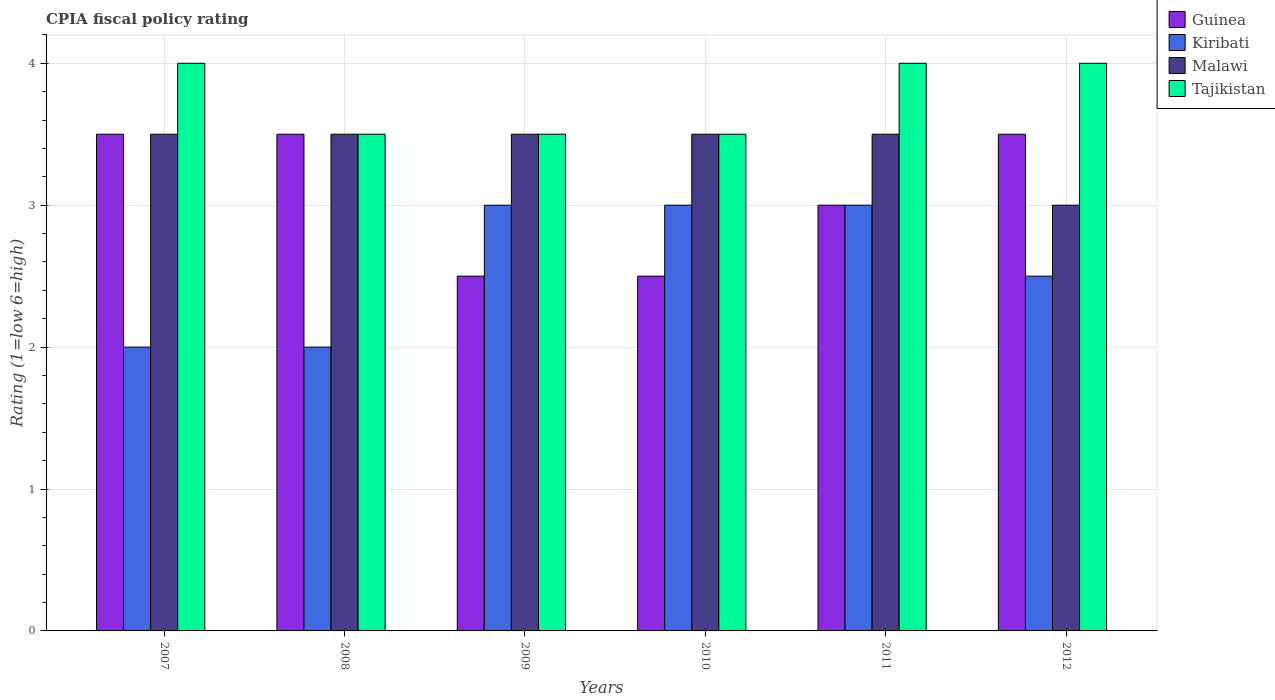How many groups of bars are there?
Ensure brevity in your answer.  6. Are the number of bars on each tick of the X-axis equal?
Provide a succinct answer. Yes. How many bars are there on the 3rd tick from the right?
Make the answer very short. 4. Across all years, what is the maximum CPIA rating in Tajikistan?
Your response must be concise. 4. In which year was the CPIA rating in Tajikistan minimum?
Your answer should be compact. 2008. What is the total CPIA rating in Kiribati in the graph?
Provide a succinct answer. 15.5. What is the difference between the CPIA rating in Kiribati in 2007 and the CPIA rating in Tajikistan in 2009?
Provide a succinct answer. -1.5. What is the average CPIA rating in Guinea per year?
Your answer should be very brief. 3.08. In the year 2012, what is the difference between the CPIA rating in Malawi and CPIA rating in Tajikistan?
Make the answer very short. -1. In how many years, is the CPIA rating in Guinea greater than 2.8?
Keep it short and to the point. 4. What is the ratio of the CPIA rating in Tajikistan in 2010 to that in 2012?
Provide a short and direct response. 0.88. Is the difference between the CPIA rating in Malawi in 2007 and 2012 greater than the difference between the CPIA rating in Tajikistan in 2007 and 2012?
Your answer should be very brief. Yes. What is the difference between the highest and the lowest CPIA rating in Guinea?
Make the answer very short. 1. In how many years, is the CPIA rating in Malawi greater than the average CPIA rating in Malawi taken over all years?
Ensure brevity in your answer.  5. What does the 1st bar from the left in 2010 represents?
Give a very brief answer. Guinea. What does the 4th bar from the right in 2012 represents?
Your answer should be very brief. Guinea. Is it the case that in every year, the sum of the CPIA rating in Guinea and CPIA rating in Malawi is greater than the CPIA rating in Kiribati?
Provide a succinct answer. Yes. Are all the bars in the graph horizontal?
Keep it short and to the point. No. Does the graph contain any zero values?
Keep it short and to the point. No. Does the graph contain grids?
Keep it short and to the point. Yes. Where does the legend appear in the graph?
Provide a succinct answer. Top right. How many legend labels are there?
Provide a succinct answer. 4. How are the legend labels stacked?
Offer a terse response. Vertical. What is the title of the graph?
Offer a very short reply. CPIA fiscal policy rating. What is the Rating (1=low 6=high) in Guinea in 2007?
Your response must be concise. 3.5. What is the Rating (1=low 6=high) in Malawi in 2007?
Make the answer very short. 3.5. What is the Rating (1=low 6=high) in Tajikistan in 2008?
Keep it short and to the point. 3.5. What is the Rating (1=low 6=high) of Kiribati in 2009?
Make the answer very short. 3. What is the Rating (1=low 6=high) of Malawi in 2009?
Offer a very short reply. 3.5. What is the Rating (1=low 6=high) in Malawi in 2010?
Provide a succinct answer. 3.5. What is the Rating (1=low 6=high) of Tajikistan in 2010?
Make the answer very short. 3.5. What is the Rating (1=low 6=high) of Kiribati in 2011?
Offer a terse response. 3. What is the Rating (1=low 6=high) of Guinea in 2012?
Provide a succinct answer. 3.5. What is the Rating (1=low 6=high) of Malawi in 2012?
Keep it short and to the point. 3. What is the Rating (1=low 6=high) of Tajikistan in 2012?
Provide a succinct answer. 4. Across all years, what is the maximum Rating (1=low 6=high) of Guinea?
Your answer should be very brief. 3.5. Across all years, what is the maximum Rating (1=low 6=high) of Tajikistan?
Make the answer very short. 4. Across all years, what is the minimum Rating (1=low 6=high) in Guinea?
Offer a very short reply. 2.5. Across all years, what is the minimum Rating (1=low 6=high) of Kiribati?
Provide a short and direct response. 2. Across all years, what is the minimum Rating (1=low 6=high) of Malawi?
Ensure brevity in your answer.  3. What is the total Rating (1=low 6=high) in Kiribati in the graph?
Ensure brevity in your answer.  15.5. What is the total Rating (1=low 6=high) in Tajikistan in the graph?
Your answer should be very brief. 22.5. What is the difference between the Rating (1=low 6=high) of Tajikistan in 2007 and that in 2008?
Provide a short and direct response. 0.5. What is the difference between the Rating (1=low 6=high) in Guinea in 2007 and that in 2009?
Ensure brevity in your answer.  1. What is the difference between the Rating (1=low 6=high) in Malawi in 2007 and that in 2009?
Ensure brevity in your answer.  0. What is the difference between the Rating (1=low 6=high) of Guinea in 2007 and that in 2010?
Your answer should be compact. 1. What is the difference between the Rating (1=low 6=high) in Malawi in 2007 and that in 2010?
Keep it short and to the point. 0. What is the difference between the Rating (1=low 6=high) in Malawi in 2007 and that in 2011?
Keep it short and to the point. 0. What is the difference between the Rating (1=low 6=high) in Tajikistan in 2007 and that in 2011?
Offer a terse response. 0. What is the difference between the Rating (1=low 6=high) of Malawi in 2007 and that in 2012?
Provide a short and direct response. 0.5. What is the difference between the Rating (1=low 6=high) of Tajikistan in 2008 and that in 2009?
Your response must be concise. 0. What is the difference between the Rating (1=low 6=high) in Malawi in 2008 and that in 2010?
Keep it short and to the point. 0. What is the difference between the Rating (1=low 6=high) of Tajikistan in 2008 and that in 2010?
Keep it short and to the point. 0. What is the difference between the Rating (1=low 6=high) in Kiribati in 2008 and that in 2011?
Give a very brief answer. -1. What is the difference between the Rating (1=low 6=high) of Malawi in 2008 and that in 2012?
Give a very brief answer. 0.5. What is the difference between the Rating (1=low 6=high) of Malawi in 2009 and that in 2010?
Give a very brief answer. 0. What is the difference between the Rating (1=low 6=high) of Guinea in 2009 and that in 2011?
Keep it short and to the point. -0.5. What is the difference between the Rating (1=low 6=high) of Malawi in 2009 and that in 2011?
Provide a short and direct response. 0. What is the difference between the Rating (1=low 6=high) of Kiribati in 2009 and that in 2012?
Your answer should be very brief. 0.5. What is the difference between the Rating (1=low 6=high) in Tajikistan in 2009 and that in 2012?
Give a very brief answer. -0.5. What is the difference between the Rating (1=low 6=high) of Guinea in 2010 and that in 2011?
Your answer should be very brief. -0.5. What is the difference between the Rating (1=low 6=high) in Kiribati in 2010 and that in 2012?
Provide a succinct answer. 0.5. What is the difference between the Rating (1=low 6=high) in Malawi in 2010 and that in 2012?
Your answer should be very brief. 0.5. What is the difference between the Rating (1=low 6=high) of Tajikistan in 2010 and that in 2012?
Offer a terse response. -0.5. What is the difference between the Rating (1=low 6=high) of Kiribati in 2011 and that in 2012?
Provide a succinct answer. 0.5. What is the difference between the Rating (1=low 6=high) of Guinea in 2007 and the Rating (1=low 6=high) of Malawi in 2008?
Your answer should be very brief. 0. What is the difference between the Rating (1=low 6=high) of Guinea in 2007 and the Rating (1=low 6=high) of Tajikistan in 2008?
Provide a succinct answer. 0. What is the difference between the Rating (1=low 6=high) of Kiribati in 2007 and the Rating (1=low 6=high) of Malawi in 2008?
Your answer should be compact. -1.5. What is the difference between the Rating (1=low 6=high) in Guinea in 2007 and the Rating (1=low 6=high) in Kiribati in 2009?
Ensure brevity in your answer.  0.5. What is the difference between the Rating (1=low 6=high) of Kiribati in 2007 and the Rating (1=low 6=high) of Tajikistan in 2009?
Your answer should be compact. -1.5. What is the difference between the Rating (1=low 6=high) of Guinea in 2007 and the Rating (1=low 6=high) of Kiribati in 2010?
Your response must be concise. 0.5. What is the difference between the Rating (1=low 6=high) of Guinea in 2007 and the Rating (1=low 6=high) of Malawi in 2010?
Offer a very short reply. 0. What is the difference between the Rating (1=low 6=high) in Guinea in 2007 and the Rating (1=low 6=high) in Tajikistan in 2010?
Ensure brevity in your answer.  0. What is the difference between the Rating (1=low 6=high) in Kiribati in 2007 and the Rating (1=low 6=high) in Tajikistan in 2010?
Offer a terse response. -1.5. What is the difference between the Rating (1=low 6=high) in Guinea in 2007 and the Rating (1=low 6=high) in Malawi in 2011?
Your answer should be compact. 0. What is the difference between the Rating (1=low 6=high) of Kiribati in 2007 and the Rating (1=low 6=high) of Malawi in 2011?
Keep it short and to the point. -1.5. What is the difference between the Rating (1=low 6=high) in Kiribati in 2007 and the Rating (1=low 6=high) in Tajikistan in 2011?
Your response must be concise. -2. What is the difference between the Rating (1=low 6=high) in Guinea in 2007 and the Rating (1=low 6=high) in Tajikistan in 2012?
Give a very brief answer. -0.5. What is the difference between the Rating (1=low 6=high) in Kiribati in 2007 and the Rating (1=low 6=high) in Malawi in 2012?
Keep it short and to the point. -1. What is the difference between the Rating (1=low 6=high) in Malawi in 2007 and the Rating (1=low 6=high) in Tajikistan in 2012?
Your response must be concise. -0.5. What is the difference between the Rating (1=low 6=high) of Guinea in 2008 and the Rating (1=low 6=high) of Kiribati in 2009?
Offer a very short reply. 0.5. What is the difference between the Rating (1=low 6=high) of Kiribati in 2008 and the Rating (1=low 6=high) of Tajikistan in 2009?
Your answer should be compact. -1.5. What is the difference between the Rating (1=low 6=high) of Guinea in 2008 and the Rating (1=low 6=high) of Malawi in 2010?
Provide a succinct answer. 0. What is the difference between the Rating (1=low 6=high) of Kiribati in 2008 and the Rating (1=low 6=high) of Malawi in 2010?
Provide a succinct answer. -1.5. What is the difference between the Rating (1=low 6=high) in Guinea in 2008 and the Rating (1=low 6=high) in Malawi in 2011?
Your response must be concise. 0. What is the difference between the Rating (1=low 6=high) of Kiribati in 2008 and the Rating (1=low 6=high) of Malawi in 2011?
Offer a terse response. -1.5. What is the difference between the Rating (1=low 6=high) of Guinea in 2008 and the Rating (1=low 6=high) of Malawi in 2012?
Your answer should be compact. 0.5. What is the difference between the Rating (1=low 6=high) in Guinea in 2008 and the Rating (1=low 6=high) in Tajikistan in 2012?
Ensure brevity in your answer.  -0.5. What is the difference between the Rating (1=low 6=high) in Kiribati in 2008 and the Rating (1=low 6=high) in Tajikistan in 2012?
Your answer should be very brief. -2. What is the difference between the Rating (1=low 6=high) of Malawi in 2008 and the Rating (1=low 6=high) of Tajikistan in 2012?
Make the answer very short. -0.5. What is the difference between the Rating (1=low 6=high) in Guinea in 2009 and the Rating (1=low 6=high) in Kiribati in 2010?
Offer a terse response. -0.5. What is the difference between the Rating (1=low 6=high) in Guinea in 2009 and the Rating (1=low 6=high) in Malawi in 2011?
Provide a succinct answer. -1. What is the difference between the Rating (1=low 6=high) of Guinea in 2009 and the Rating (1=low 6=high) of Tajikistan in 2011?
Offer a very short reply. -1.5. What is the difference between the Rating (1=low 6=high) in Guinea in 2009 and the Rating (1=low 6=high) in Kiribati in 2012?
Make the answer very short. 0. What is the difference between the Rating (1=low 6=high) in Guinea in 2009 and the Rating (1=low 6=high) in Malawi in 2012?
Your answer should be very brief. -0.5. What is the difference between the Rating (1=low 6=high) of Guinea in 2009 and the Rating (1=low 6=high) of Tajikistan in 2012?
Offer a very short reply. -1.5. What is the difference between the Rating (1=low 6=high) of Kiribati in 2009 and the Rating (1=low 6=high) of Tajikistan in 2012?
Make the answer very short. -1. What is the difference between the Rating (1=low 6=high) of Guinea in 2010 and the Rating (1=low 6=high) of Kiribati in 2011?
Make the answer very short. -0.5. What is the difference between the Rating (1=low 6=high) of Malawi in 2010 and the Rating (1=low 6=high) of Tajikistan in 2011?
Provide a short and direct response. -0.5. What is the difference between the Rating (1=low 6=high) of Malawi in 2010 and the Rating (1=low 6=high) of Tajikistan in 2012?
Offer a very short reply. -0.5. What is the difference between the Rating (1=low 6=high) of Guinea in 2011 and the Rating (1=low 6=high) of Kiribati in 2012?
Give a very brief answer. 0.5. What is the difference between the Rating (1=low 6=high) of Guinea in 2011 and the Rating (1=low 6=high) of Tajikistan in 2012?
Your response must be concise. -1. What is the difference between the Rating (1=low 6=high) of Kiribati in 2011 and the Rating (1=low 6=high) of Malawi in 2012?
Make the answer very short. 0. What is the average Rating (1=low 6=high) in Guinea per year?
Keep it short and to the point. 3.08. What is the average Rating (1=low 6=high) of Kiribati per year?
Provide a succinct answer. 2.58. What is the average Rating (1=low 6=high) in Malawi per year?
Ensure brevity in your answer.  3.42. What is the average Rating (1=low 6=high) of Tajikistan per year?
Your answer should be very brief. 3.75. In the year 2007, what is the difference between the Rating (1=low 6=high) in Guinea and Rating (1=low 6=high) in Malawi?
Provide a short and direct response. 0. In the year 2007, what is the difference between the Rating (1=low 6=high) in Kiribati and Rating (1=low 6=high) in Tajikistan?
Provide a succinct answer. -2. In the year 2007, what is the difference between the Rating (1=low 6=high) in Malawi and Rating (1=low 6=high) in Tajikistan?
Make the answer very short. -0.5. In the year 2008, what is the difference between the Rating (1=low 6=high) of Guinea and Rating (1=low 6=high) of Tajikistan?
Give a very brief answer. 0. In the year 2008, what is the difference between the Rating (1=low 6=high) in Kiribati and Rating (1=low 6=high) in Tajikistan?
Make the answer very short. -1.5. In the year 2008, what is the difference between the Rating (1=low 6=high) of Malawi and Rating (1=low 6=high) of Tajikistan?
Offer a very short reply. 0. In the year 2009, what is the difference between the Rating (1=low 6=high) in Guinea and Rating (1=low 6=high) in Malawi?
Your response must be concise. -1. In the year 2009, what is the difference between the Rating (1=low 6=high) of Kiribati and Rating (1=low 6=high) of Malawi?
Your answer should be compact. -0.5. In the year 2009, what is the difference between the Rating (1=low 6=high) in Malawi and Rating (1=low 6=high) in Tajikistan?
Offer a terse response. 0. In the year 2010, what is the difference between the Rating (1=low 6=high) of Kiribati and Rating (1=low 6=high) of Malawi?
Make the answer very short. -0.5. In the year 2010, what is the difference between the Rating (1=low 6=high) of Malawi and Rating (1=low 6=high) of Tajikistan?
Provide a succinct answer. 0. In the year 2011, what is the difference between the Rating (1=low 6=high) in Guinea and Rating (1=low 6=high) in Tajikistan?
Give a very brief answer. -1. In the year 2011, what is the difference between the Rating (1=low 6=high) in Kiribati and Rating (1=low 6=high) in Malawi?
Make the answer very short. -0.5. In the year 2011, what is the difference between the Rating (1=low 6=high) in Malawi and Rating (1=low 6=high) in Tajikistan?
Keep it short and to the point. -0.5. In the year 2012, what is the difference between the Rating (1=low 6=high) in Guinea and Rating (1=low 6=high) in Kiribati?
Offer a terse response. 1. In the year 2012, what is the difference between the Rating (1=low 6=high) of Guinea and Rating (1=low 6=high) of Tajikistan?
Offer a terse response. -0.5. In the year 2012, what is the difference between the Rating (1=low 6=high) of Kiribati and Rating (1=low 6=high) of Malawi?
Ensure brevity in your answer.  -0.5. What is the ratio of the Rating (1=low 6=high) in Tajikistan in 2007 to that in 2008?
Your response must be concise. 1.14. What is the ratio of the Rating (1=low 6=high) of Kiribati in 2007 to that in 2009?
Provide a succinct answer. 0.67. What is the ratio of the Rating (1=low 6=high) in Malawi in 2007 to that in 2009?
Keep it short and to the point. 1. What is the ratio of the Rating (1=low 6=high) of Tajikistan in 2007 to that in 2009?
Provide a short and direct response. 1.14. What is the ratio of the Rating (1=low 6=high) in Tajikistan in 2007 to that in 2010?
Offer a very short reply. 1.14. What is the ratio of the Rating (1=low 6=high) in Guinea in 2007 to that in 2011?
Offer a terse response. 1.17. What is the ratio of the Rating (1=low 6=high) of Malawi in 2007 to that in 2011?
Your answer should be compact. 1. What is the ratio of the Rating (1=low 6=high) of Kiribati in 2007 to that in 2012?
Give a very brief answer. 0.8. What is the ratio of the Rating (1=low 6=high) of Malawi in 2007 to that in 2012?
Give a very brief answer. 1.17. What is the ratio of the Rating (1=low 6=high) of Guinea in 2008 to that in 2009?
Your response must be concise. 1.4. What is the ratio of the Rating (1=low 6=high) in Malawi in 2008 to that in 2009?
Your answer should be very brief. 1. What is the ratio of the Rating (1=low 6=high) in Guinea in 2008 to that in 2010?
Your answer should be compact. 1.4. What is the ratio of the Rating (1=low 6=high) in Kiribati in 2008 to that in 2010?
Ensure brevity in your answer.  0.67. What is the ratio of the Rating (1=low 6=high) of Tajikistan in 2008 to that in 2010?
Offer a very short reply. 1. What is the ratio of the Rating (1=low 6=high) of Kiribati in 2008 to that in 2012?
Keep it short and to the point. 0.8. What is the ratio of the Rating (1=low 6=high) of Malawi in 2008 to that in 2012?
Offer a very short reply. 1.17. What is the ratio of the Rating (1=low 6=high) of Tajikistan in 2008 to that in 2012?
Make the answer very short. 0.88. What is the ratio of the Rating (1=low 6=high) of Kiribati in 2009 to that in 2010?
Make the answer very short. 1. What is the ratio of the Rating (1=low 6=high) of Tajikistan in 2009 to that in 2010?
Give a very brief answer. 1. What is the ratio of the Rating (1=low 6=high) of Malawi in 2009 to that in 2011?
Provide a succinct answer. 1. What is the ratio of the Rating (1=low 6=high) in Guinea in 2009 to that in 2012?
Provide a short and direct response. 0.71. What is the ratio of the Rating (1=low 6=high) in Kiribati in 2009 to that in 2012?
Your answer should be compact. 1.2. What is the ratio of the Rating (1=low 6=high) in Malawi in 2009 to that in 2012?
Your response must be concise. 1.17. What is the ratio of the Rating (1=low 6=high) in Guinea in 2010 to that in 2011?
Ensure brevity in your answer.  0.83. What is the ratio of the Rating (1=low 6=high) of Kiribati in 2010 to that in 2011?
Offer a very short reply. 1. What is the ratio of the Rating (1=low 6=high) of Guinea in 2010 to that in 2012?
Provide a short and direct response. 0.71. What is the ratio of the Rating (1=low 6=high) in Kiribati in 2010 to that in 2012?
Your answer should be compact. 1.2. What is the ratio of the Rating (1=low 6=high) in Malawi in 2010 to that in 2012?
Provide a succinct answer. 1.17. What is the ratio of the Rating (1=low 6=high) in Guinea in 2011 to that in 2012?
Ensure brevity in your answer.  0.86. What is the ratio of the Rating (1=low 6=high) of Kiribati in 2011 to that in 2012?
Make the answer very short. 1.2. What is the difference between the highest and the second highest Rating (1=low 6=high) of Malawi?
Ensure brevity in your answer.  0. What is the difference between the highest and the second highest Rating (1=low 6=high) of Tajikistan?
Your answer should be compact. 0. What is the difference between the highest and the lowest Rating (1=low 6=high) of Kiribati?
Make the answer very short. 1. 